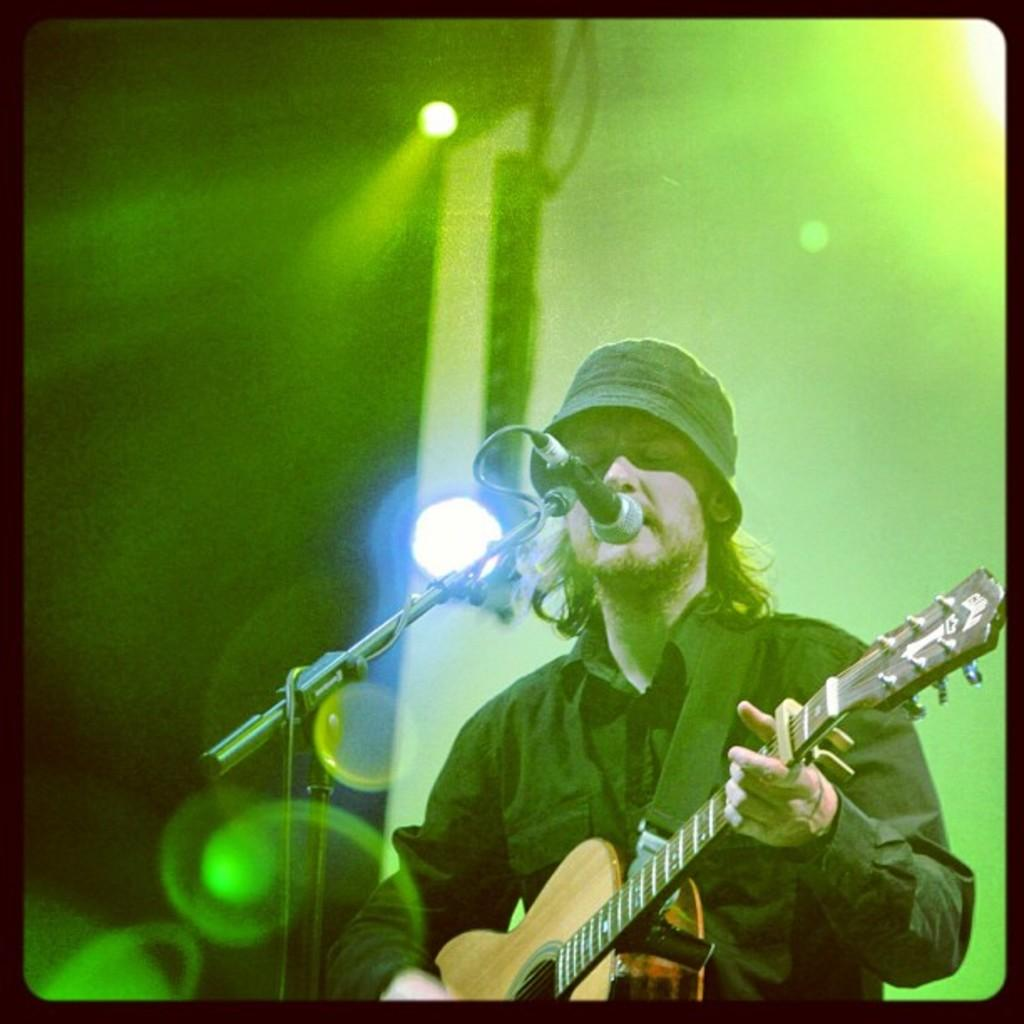What is the person in the image doing? The person is playing a guitar and singing. What is the person wearing? The person is wearing a black shirt. What object is in front of the person? There is a microphone in front of the person. What can be seen in the background of the image? Green lights are attached to the roof in the background. How does the fog affect the person's performance in the image? There is no fog present in the image. 